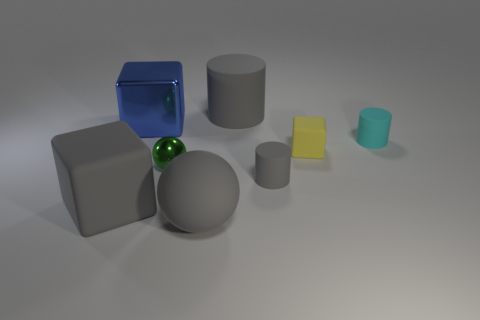Subtract all big gray matte cylinders. How many cylinders are left? 2 Add 1 big blue shiny cubes. How many objects exist? 9 Subtract all gray blocks. How many blocks are left? 2 Subtract 1 blocks. How many blocks are left? 2 Subtract all cubes. How many objects are left? 5 Subtract all green blocks. Subtract all brown cylinders. How many blocks are left? 3 Subtract all gray cylinders. How many gray cubes are left? 1 Subtract all tiny yellow cylinders. Subtract all yellow objects. How many objects are left? 7 Add 7 small cylinders. How many small cylinders are left? 9 Add 3 gray matte spheres. How many gray matte spheres exist? 4 